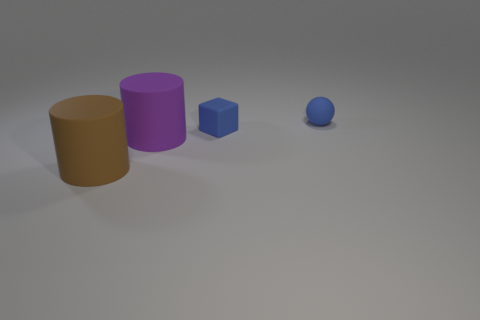Add 2 tiny gray metallic cubes. How many objects exist? 6 Subtract all spheres. How many objects are left? 3 Add 2 small balls. How many small balls are left? 3 Add 2 purple rubber objects. How many purple rubber objects exist? 3 Subtract 0 cyan balls. How many objects are left? 4 Subtract all tiny blue matte balls. Subtract all tiny yellow rubber things. How many objects are left? 3 